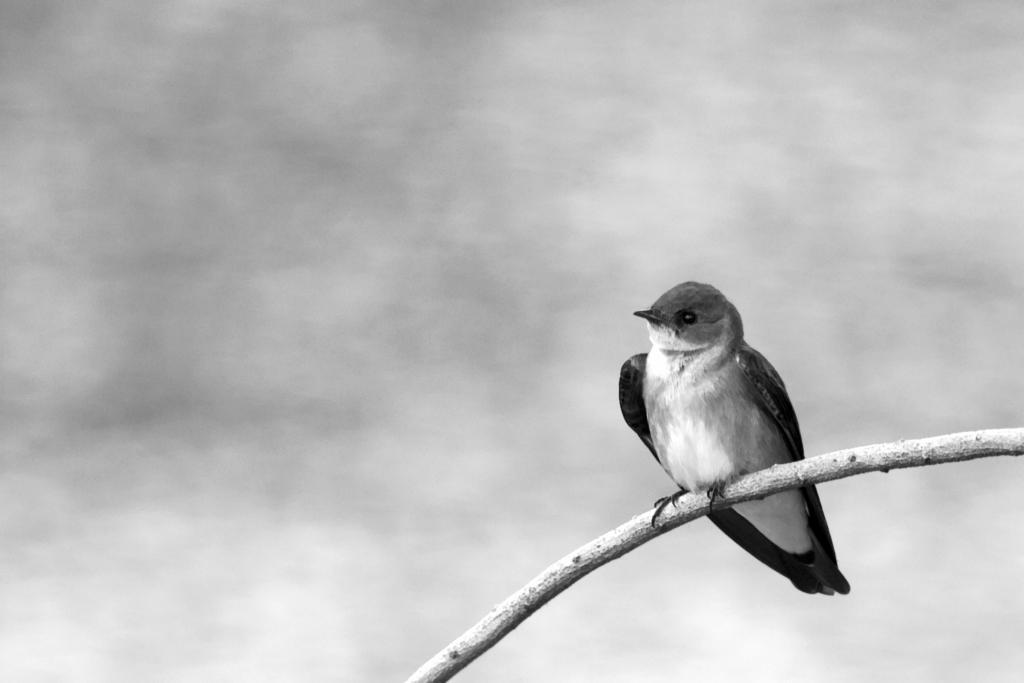In one or two sentences, can you explain what this image depicts? In this image we can see a bird sitting on a branch of a tree/plant. 